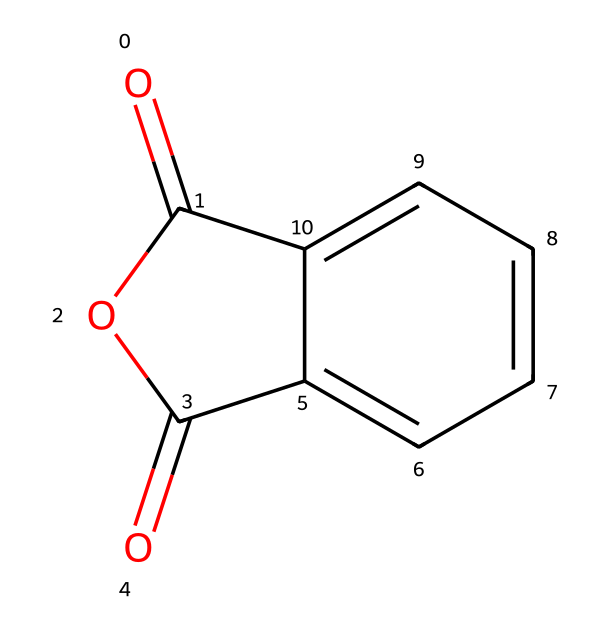What is the name of the chemical represented by the SMILES? The SMILES notation indicates the structure of the chemical, which includes a cyclic anhydride and a phenyl group. This corresponds to phthalic anhydride.
Answer: phthalic anhydride How many carbon atoms are in phthalic anhydride? By examining the structure in the SMILES, we can count the number of carbon atoms present. There are 8 carbon atoms in total in the structure.
Answer: 8 What type of functional groups are present in phthalic anhydride? The presence of "OC(=O)" indicates carboxylic anhydride functionality, which is characteristic of acid anhydrides. This means it contains an anhydride group.
Answer: anhydride What is the total number of oxygen atoms in phthalic anhydride? The SMILES structure shows two anhydride oxygen atoms and one additional oxygen as part of the cyclic structure. Adding those gives a total of 3 oxygen atoms.
Answer: 3 Is phthalic anhydride a solid or liquid at room temperature? The structural features of phthalic anhydride suggest it has a relatively high melting point, indicating it is a solid at room temperature.
Answer: solid How many double bonds are present in the structure of phthalic anhydride? The SMILES representation shows several bonds, including double bonds between carbon and oxygen in the anhydride and aromatic ring, totaling 4 double bonds in the structure.
Answer: 4 